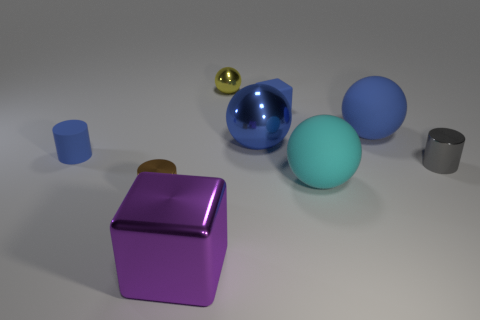Add 1 large metallic blocks. How many objects exist? 10 Subtract all cylinders. How many objects are left? 6 Subtract all big matte things. Subtract all small blue cubes. How many objects are left? 6 Add 1 tiny rubber cubes. How many tiny rubber cubes are left? 2 Add 1 big blue rubber spheres. How many big blue rubber spheres exist? 2 Subtract 1 brown cylinders. How many objects are left? 8 